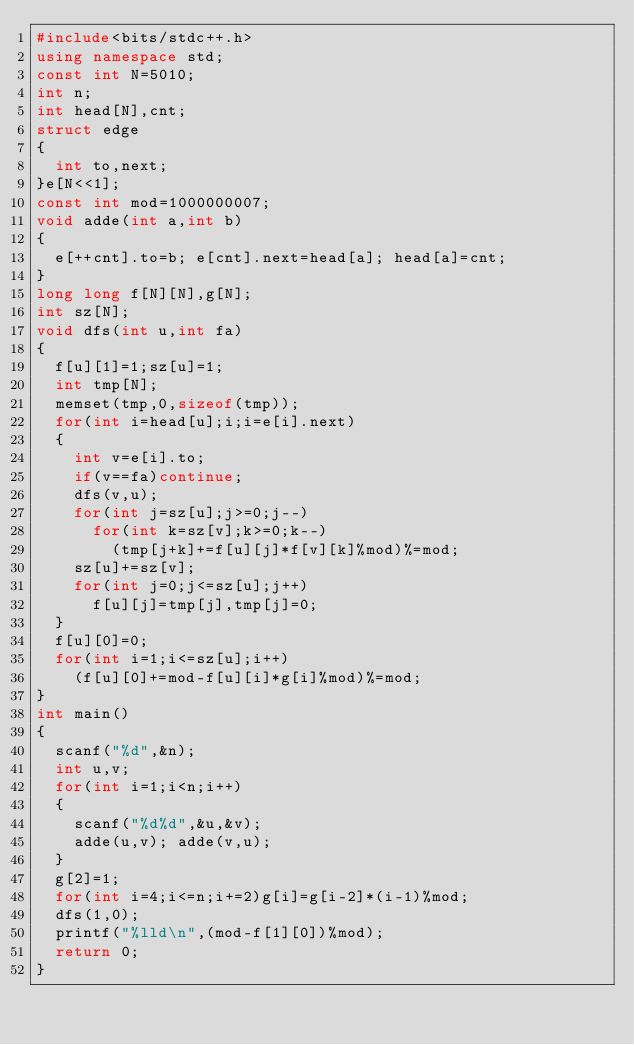<code> <loc_0><loc_0><loc_500><loc_500><_C++_>#include<bits/stdc++.h>
using namespace std;
const int N=5010;
int n;
int head[N],cnt;
struct edge
{
	int to,next;
}e[N<<1];
const int mod=1000000007;
void adde(int a,int b)
{
	e[++cnt].to=b; e[cnt].next=head[a]; head[a]=cnt;
}
long long f[N][N],g[N];
int sz[N];
void dfs(int u,int fa)
{
	f[u][1]=1;sz[u]=1;
	int tmp[N];
	memset(tmp,0,sizeof(tmp));
	for(int i=head[u];i;i=e[i].next)
	{
		int v=e[i].to;
		if(v==fa)continue;
		dfs(v,u);
		for(int j=sz[u];j>=0;j--)
			for(int k=sz[v];k>=0;k--)
				(tmp[j+k]+=f[u][j]*f[v][k]%mod)%=mod;
		sz[u]+=sz[v];
		for(int j=0;j<=sz[u];j++)
			f[u][j]=tmp[j],tmp[j]=0;
	}
	f[u][0]=0;
	for(int i=1;i<=sz[u];i++)
		(f[u][0]+=mod-f[u][i]*g[i]%mod)%=mod;
}
int main()
{
	scanf("%d",&n);
	int u,v;
	for(int i=1;i<n;i++)
	{
		scanf("%d%d",&u,&v);
		adde(u,v); adde(v,u);
	}
	g[2]=1;
	for(int i=4;i<=n;i+=2)g[i]=g[i-2]*(i-1)%mod;
	dfs(1,0);
	printf("%lld\n",(mod-f[1][0])%mod);
	return 0;
}
</code> 